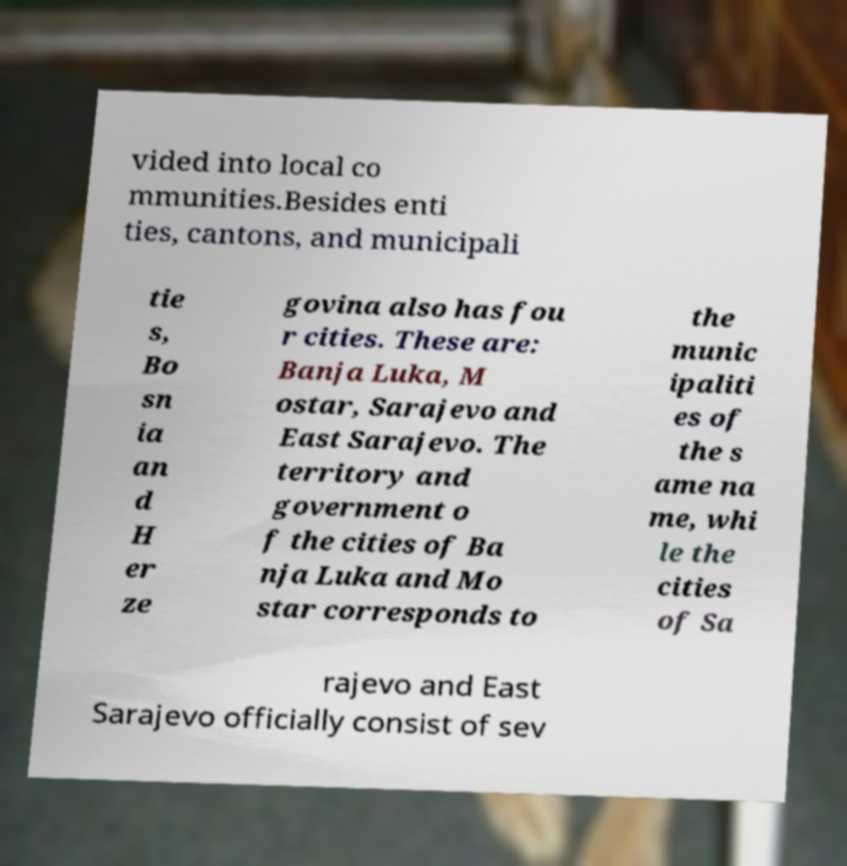Could you extract and type out the text from this image? vided into local co mmunities.Besides enti ties, cantons, and municipali tie s, Bo sn ia an d H er ze govina also has fou r cities. These are: Banja Luka, M ostar, Sarajevo and East Sarajevo. The territory and government o f the cities of Ba nja Luka and Mo star corresponds to the munic ipaliti es of the s ame na me, whi le the cities of Sa rajevo and East Sarajevo officially consist of sev 